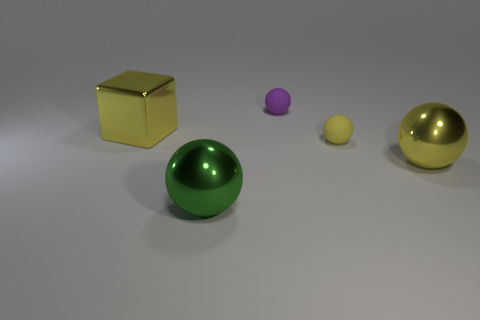Subtract all green balls. How many balls are left? 3 Subtract all large green spheres. How many spheres are left? 3 Subtract all blue spheres. Subtract all brown blocks. How many spheres are left? 4 Add 4 metal blocks. How many objects exist? 9 Subtract all blocks. How many objects are left? 4 Add 3 yellow shiny objects. How many yellow shiny objects are left? 5 Add 3 tiny yellow metallic cubes. How many tiny yellow metallic cubes exist? 3 Subtract 0 red cylinders. How many objects are left? 5 Subtract all big yellow metallic things. Subtract all large green metal balls. How many objects are left? 2 